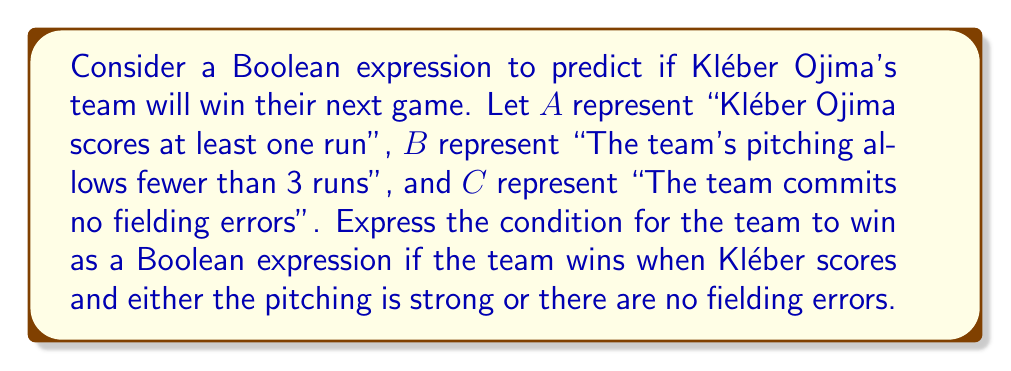Could you help me with this problem? To solve this problem, we need to translate the given conditions into a Boolean expression:

1. Kléber Ojima must score at least one run: This is represented by $A$.
2. Either the team's pitching allows fewer than 3 runs (represented by $B$) OR the team commits no fielding errors (represented by $C$).
3. Both conditions 1 and 2 must be true for the team to win.

We can express this logically as:
$A$ AND ($B$ OR $C$)

In Boolean algebra notation, this is written as:

$$A \land (B \lor C)$$

Where:
- $\land$ represents the AND operation
- $\lor$ represents the OR operation

This expression accurately captures the conditions for the team to win:
- Kléber Ojima must score ($A$ must be true)
- AND
- Either the pitching is strong ($B$ is true) or there are no fielding errors ($C$ is true)

If this entire expression evaluates to true, the prediction is that the team will win the next game.
Answer: $A \land (B \lor C)$ 